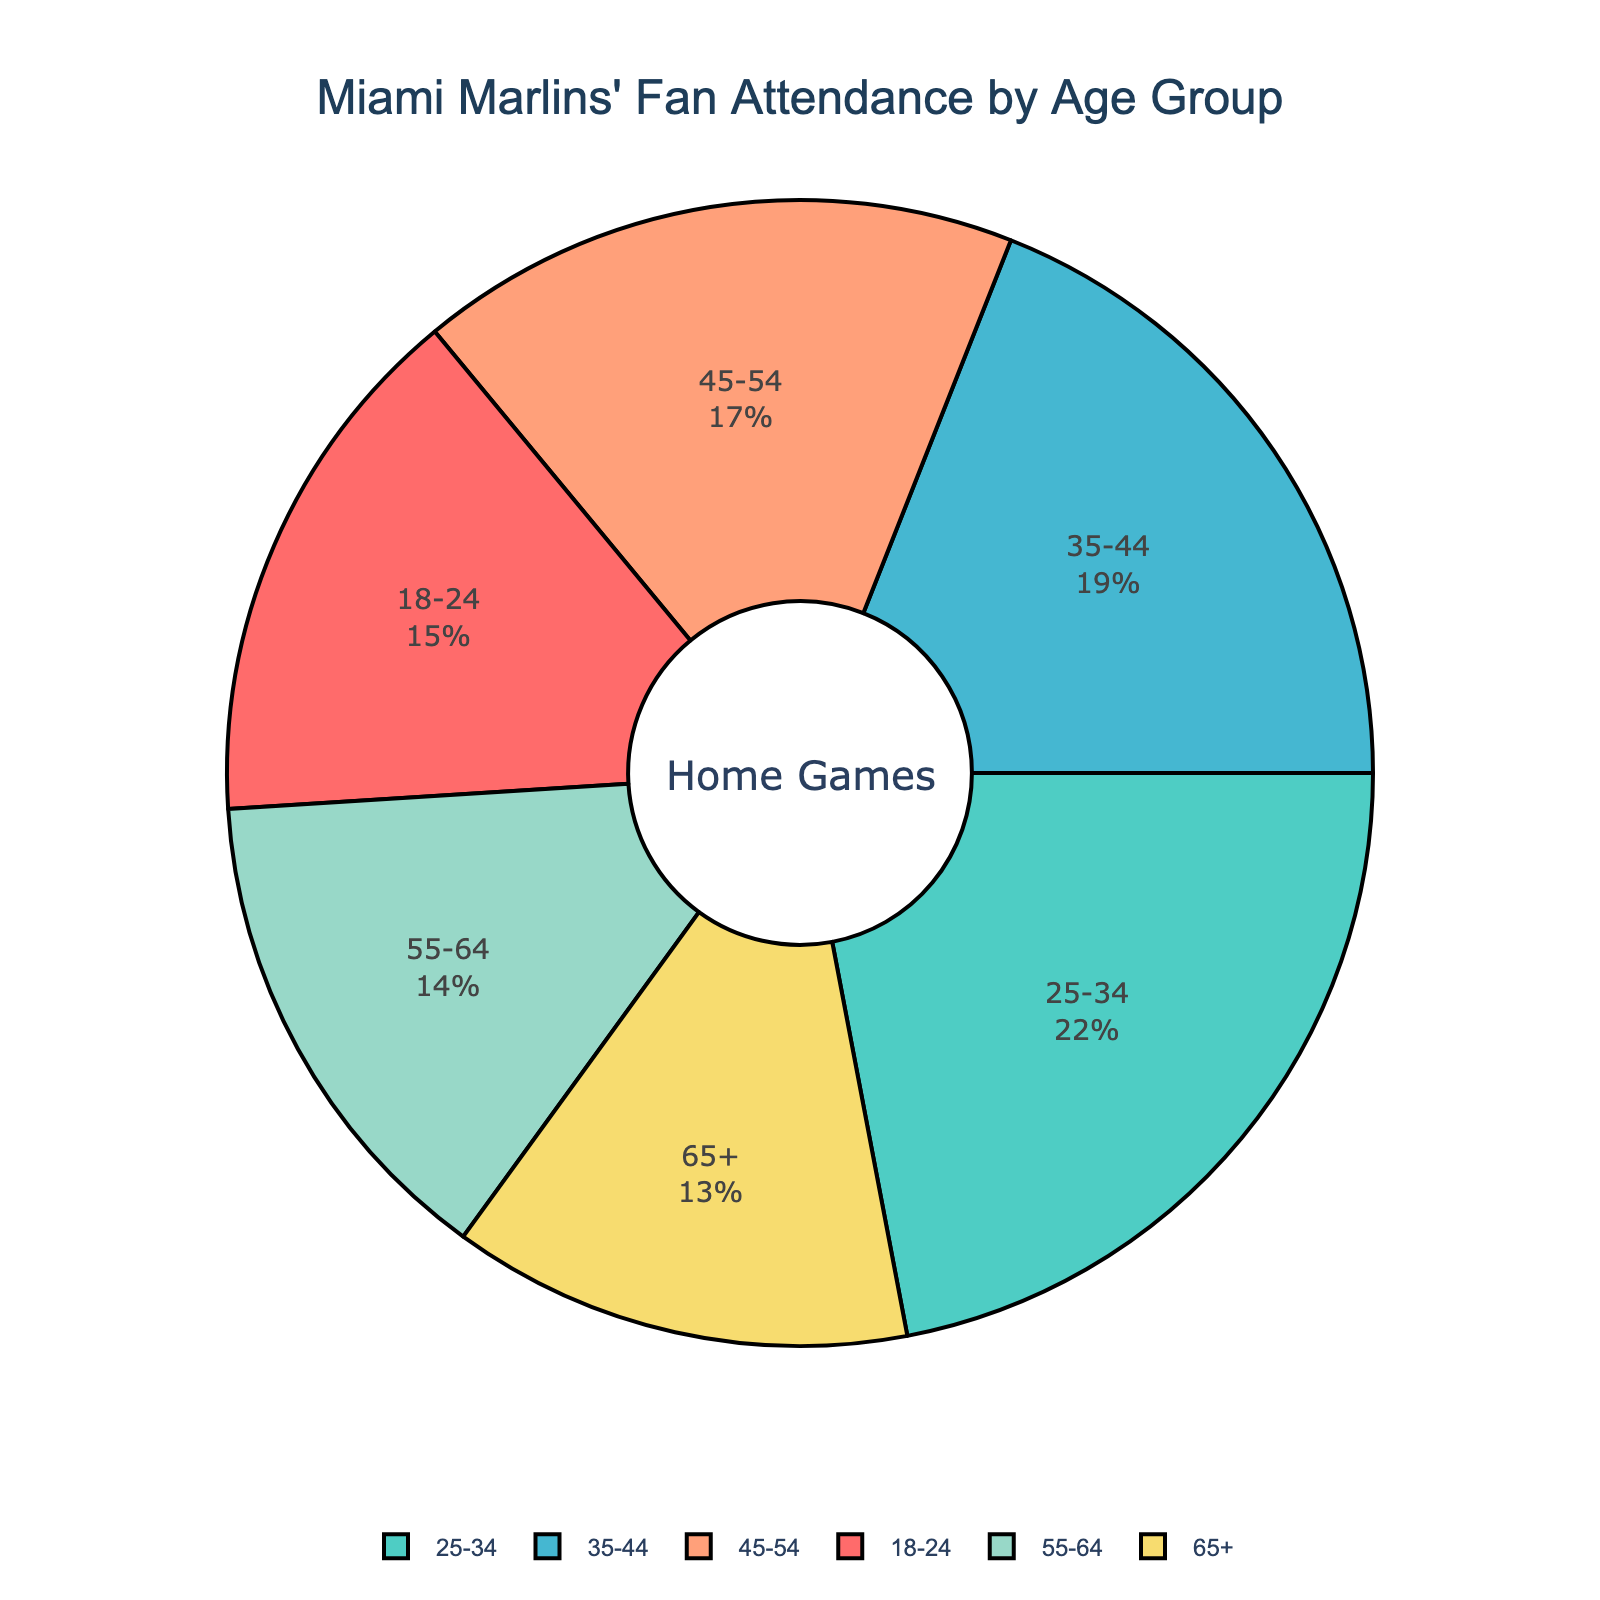What age group has the highest percentage of fan attendance at Miami Marlins' home games? According to the pie chart, the 25-34 age group has the highest percentage of fan attendance.
Answer: 25-34 Which age group has the least fan attendance at the games? The age group 65+ has the smallest segment in the pie chart, indicating the least fan attendance.
Answer: 65+ How much more is the percentage of fans aged 25-34 compared to fans aged 18-24? The percentage of fans aged 25-34 is 22%, while for the 18-24 age group, it's 15%. The difference is 22% - 15% = 7%.
Answer: 7% What is the combined percentage of fans aged 45 and above? Summing the percentages of the 45-54, 55-64, and 65+ age groups: 17% + 14% + 13% = 44%.
Answer: 44% Which age groups together account for at least 50% of the fan attendance? 25-34 (22%), 35-44 (19%), and 18-24 (15%) age groups combined: 22% + 19% + 15% = 56%, which is more than 50%.
Answer: 18-24, 25-34, 35-44 What is the median age group for the fan attendance percentages? Listing the percentages in ascending order: 13%, 14%, 15%, 17%, 19%, 22%. The median falls between the 3rd and 4th values. So, (15% + 17%) / 2 = 16%. The middle age groups are 18-24 and 45-54.
Answer: 18-24, 45-54 If the 25-34 age group is represented by a segment colored teal, what color represents the 55-64 age group? The order of colors matches the order of age groups. If 25-34 is teal (second color), 55-64 would be the fifth color, which is green.
Answer: green Which age group’s percentage is closest to the average percentage of all age groups? The average percentage = (15% + 22% + 19% + 17% + 14% + 13%) / 6 ≈ 16.7%. The 18-24 age group at 15% is closest to this average.
Answer: 18-24 Which two age groups have the most similar fan attendance percentages? Comparing the percentages: 15% (18-24), 22% (25-34), 19% (35-44), 17% (45-54), 14% (55-64), 13% (65+). The age groups 55-64 (14%) and 65+ (13%) have the most similar percentages.
Answer: 55-64, 65+ How much more fan attendance does the 35-44 age group have than the 65+ age group? The percentage for 35-44 is 19%, and for 65+ it's 13%. The difference is 19% - 13% = 6%.
Answer: 6% 